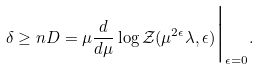<formula> <loc_0><loc_0><loc_500><loc_500>\delta \geq n { D } = \mu \frac { d } { d \mu } \log \mathcal { Z } ( \mu ^ { 2 \epsilon } \lambda , \epsilon ) \Big | _ { \epsilon = 0 } .</formula> 